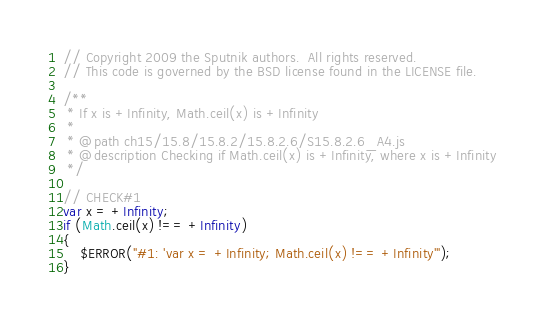Convert code to text. <code><loc_0><loc_0><loc_500><loc_500><_JavaScript_>// Copyright 2009 the Sputnik authors.  All rights reserved.
// This code is governed by the BSD license found in the LICENSE file.

/**
 * If x is +Infinity, Math.ceil(x) is +Infinity
 *
 * @path ch15/15.8/15.8.2/15.8.2.6/S15.8.2.6_A4.js
 * @description Checking if Math.ceil(x) is +Infinity, where x is +Infinity
 */

// CHECK#1
var x = +Infinity;
if (Math.ceil(x) !== +Infinity)
{
	$ERROR("#1: 'var x = +Infinity; Math.ceil(x) !== +Infinity'");
}

</code> 